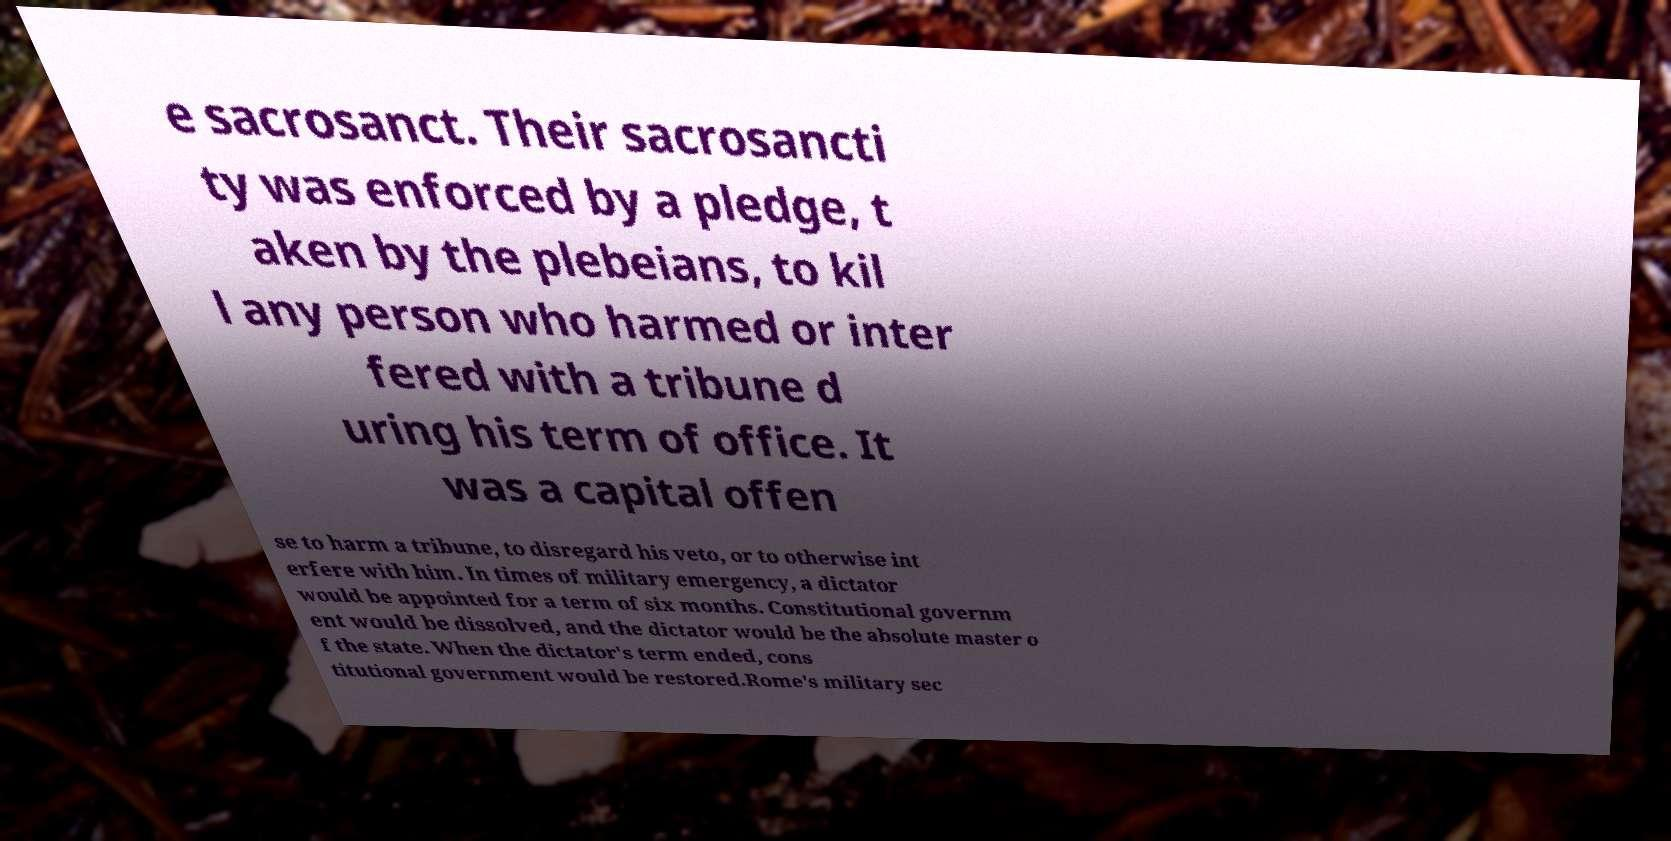Could you assist in decoding the text presented in this image and type it out clearly? e sacrosanct. Their sacrosancti ty was enforced by a pledge, t aken by the plebeians, to kil l any person who harmed or inter fered with a tribune d uring his term of office. It was a capital offen se to harm a tribune, to disregard his veto, or to otherwise int erfere with him. In times of military emergency, a dictator would be appointed for a term of six months. Constitutional governm ent would be dissolved, and the dictator would be the absolute master o f the state. When the dictator's term ended, cons titutional government would be restored.Rome's military sec 